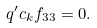Convert formula to latex. <formula><loc_0><loc_0><loc_500><loc_500>q ^ { \prime } c _ { k } f _ { 3 3 } = 0 .</formula> 